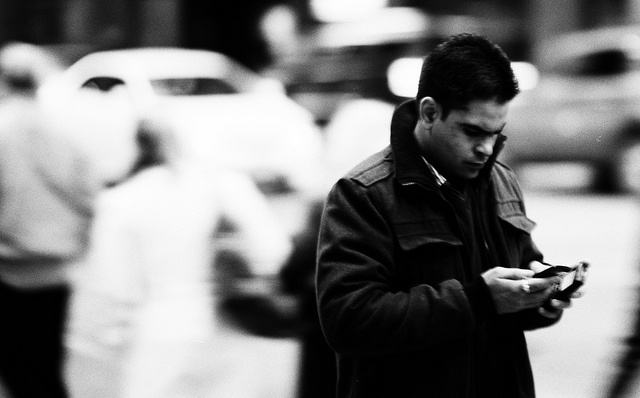Describe the objects in this image and their specific colors. I can see people in black, gray, darkgray, and lightgray tones, car in black, white, darkgray, and gray tones, people in black, lightgray, darkgray, and gray tones, car in black, darkgray, gray, and lightgray tones, and cell phone in black, gainsboro, darkgray, and gray tones in this image. 